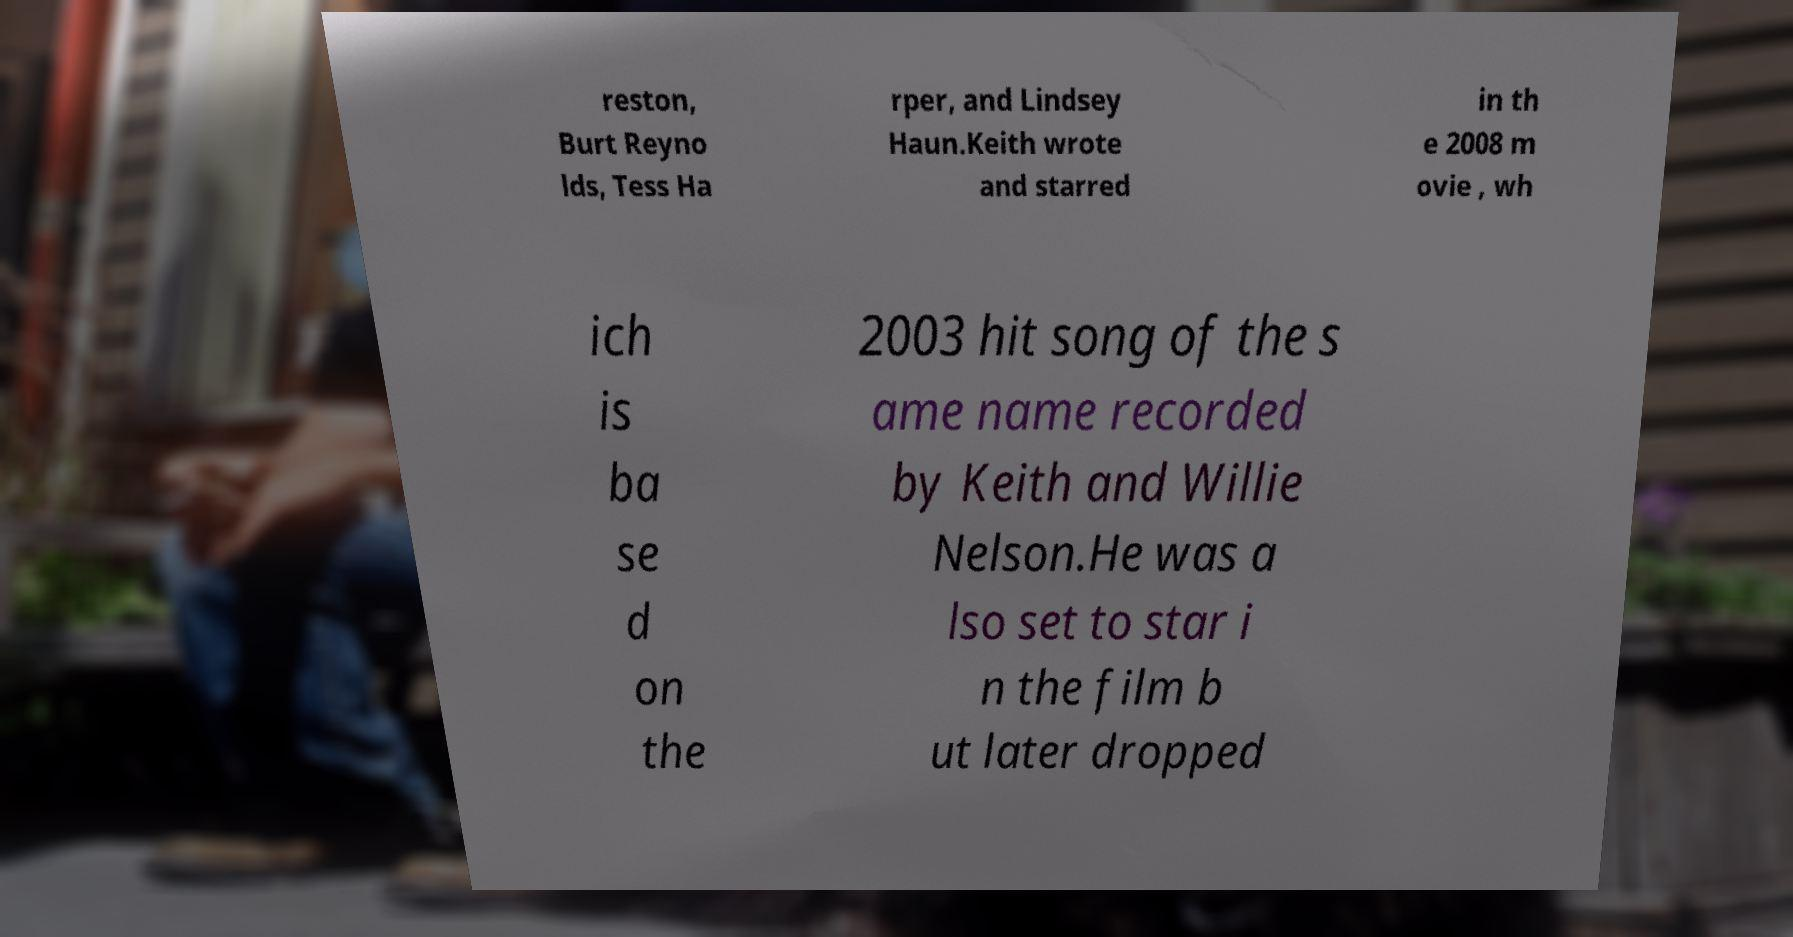I need the written content from this picture converted into text. Can you do that? reston, Burt Reyno lds, Tess Ha rper, and Lindsey Haun.Keith wrote and starred in th e 2008 m ovie , wh ich is ba se d on the 2003 hit song of the s ame name recorded by Keith and Willie Nelson.He was a lso set to star i n the film b ut later dropped 